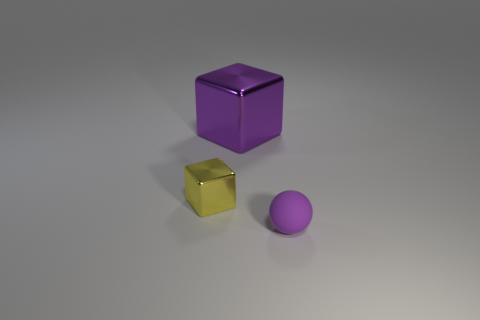Add 2 tiny brown things. How many objects exist? 5 Subtract all spheres. How many objects are left? 2 Subtract 0 purple cylinders. How many objects are left? 3 Subtract all brown metal balls. Subtract all purple metallic objects. How many objects are left? 2 Add 1 spheres. How many spheres are left? 2 Add 1 small green matte balls. How many small green matte balls exist? 1 